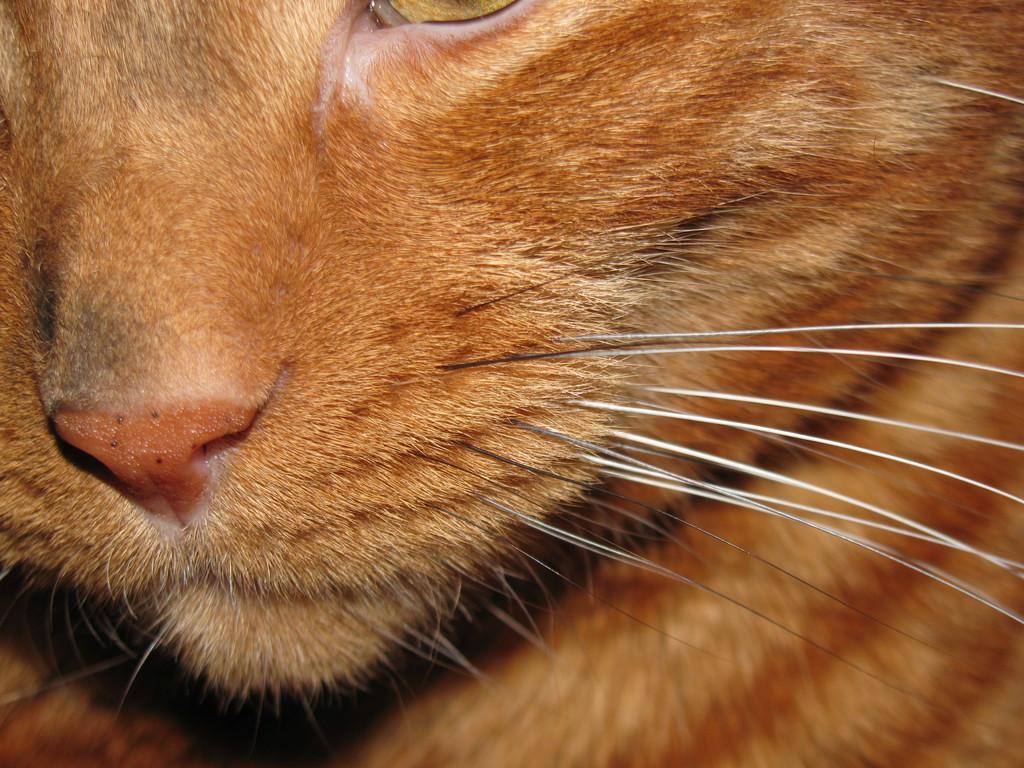In one or two sentences, can you explain what this image depicts? In this image, I think this is a cat, which is light brown in color. I can see a nose, whiskers and an eye of a cat. 